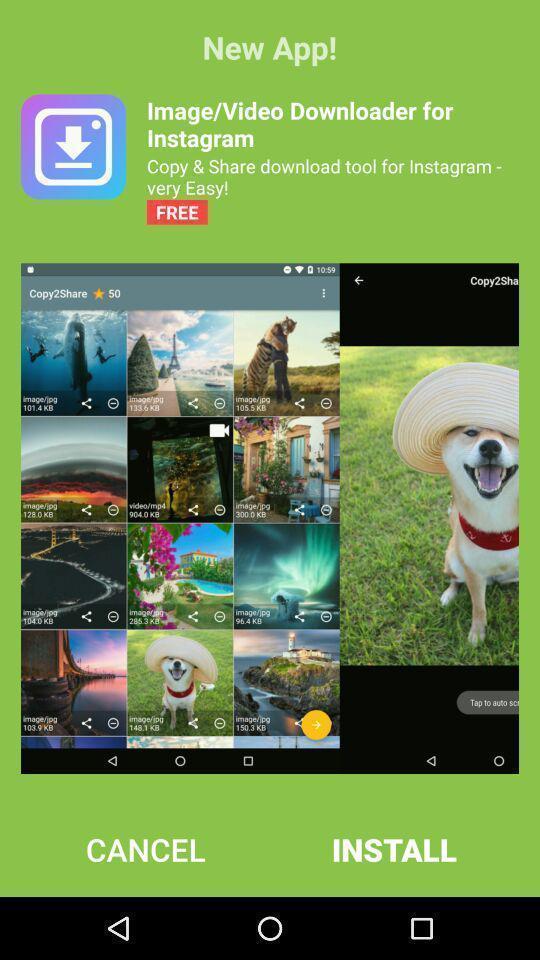Tell me what you see in this picture. Screen displaying the install option for an app. 